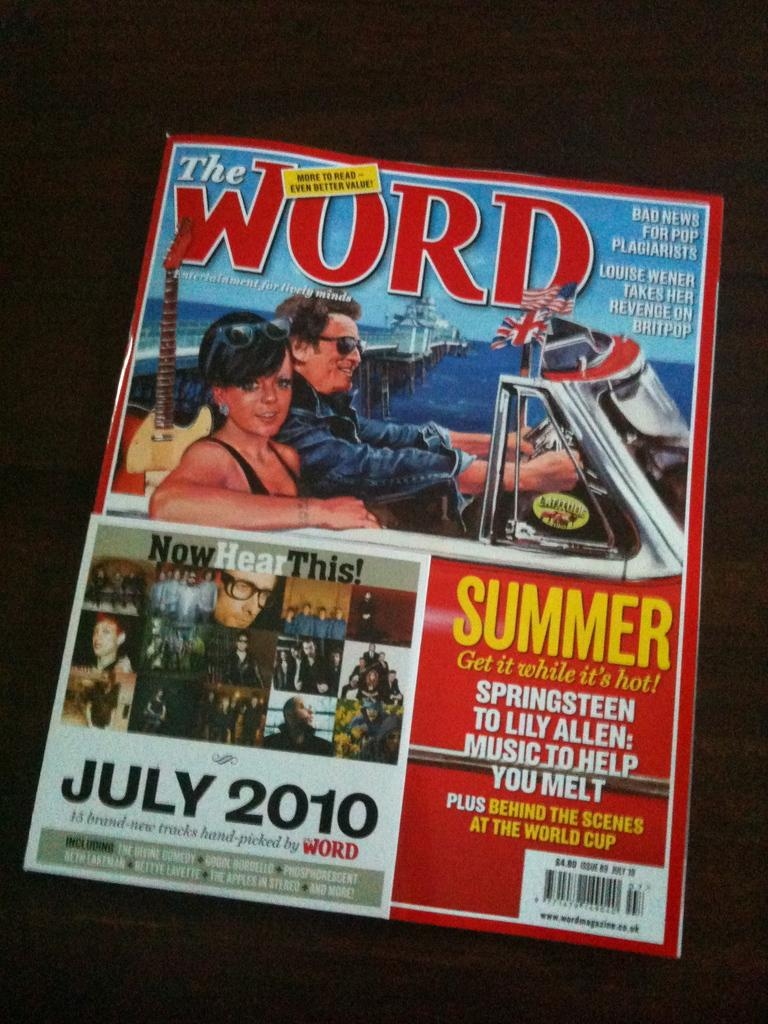What is the main object in the image? There is a magazine in the image. What type of content is featured on the magazine cover? The magazine cover has a photo of two persons going in a car above and below, as well as a photo grid image of various persons. What type of metal is used to make the trousers worn by the persons in the photo grid image? There is no information about the type of metal used for trousers in the image, as the focus is on the magazine and its content. 